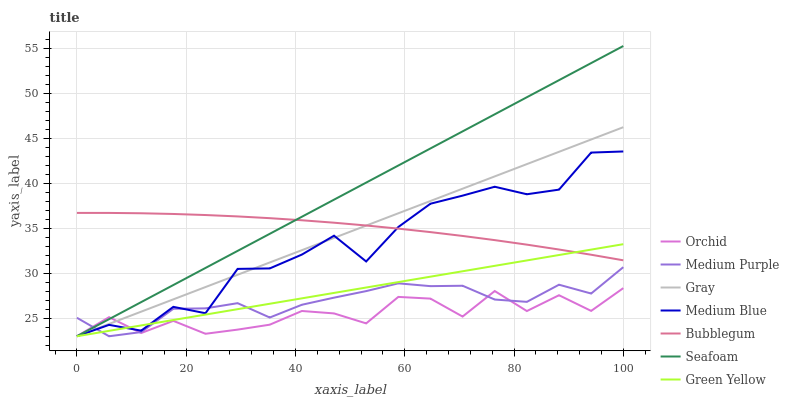Does Orchid have the minimum area under the curve?
Answer yes or no. Yes. Does Seafoam have the maximum area under the curve?
Answer yes or no. Yes. Does Medium Blue have the minimum area under the curve?
Answer yes or no. No. Does Medium Blue have the maximum area under the curve?
Answer yes or no. No. Is Green Yellow the smoothest?
Answer yes or no. Yes. Is Medium Blue the roughest?
Answer yes or no. Yes. Is Seafoam the smoothest?
Answer yes or no. No. Is Seafoam the roughest?
Answer yes or no. No. Does Gray have the lowest value?
Answer yes or no. Yes. Does Bubblegum have the lowest value?
Answer yes or no. No. Does Seafoam have the highest value?
Answer yes or no. Yes. Does Medium Blue have the highest value?
Answer yes or no. No. Is Orchid less than Bubblegum?
Answer yes or no. Yes. Is Bubblegum greater than Orchid?
Answer yes or no. Yes. Does Gray intersect Bubblegum?
Answer yes or no. Yes. Is Gray less than Bubblegum?
Answer yes or no. No. Is Gray greater than Bubblegum?
Answer yes or no. No. Does Orchid intersect Bubblegum?
Answer yes or no. No. 